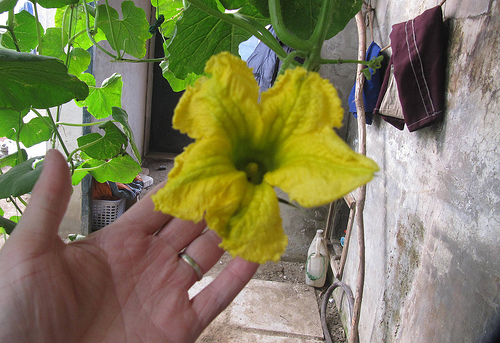<image>
Is the flower on the leaf? Yes. Looking at the image, I can see the flower is positioned on top of the leaf, with the leaf providing support. 